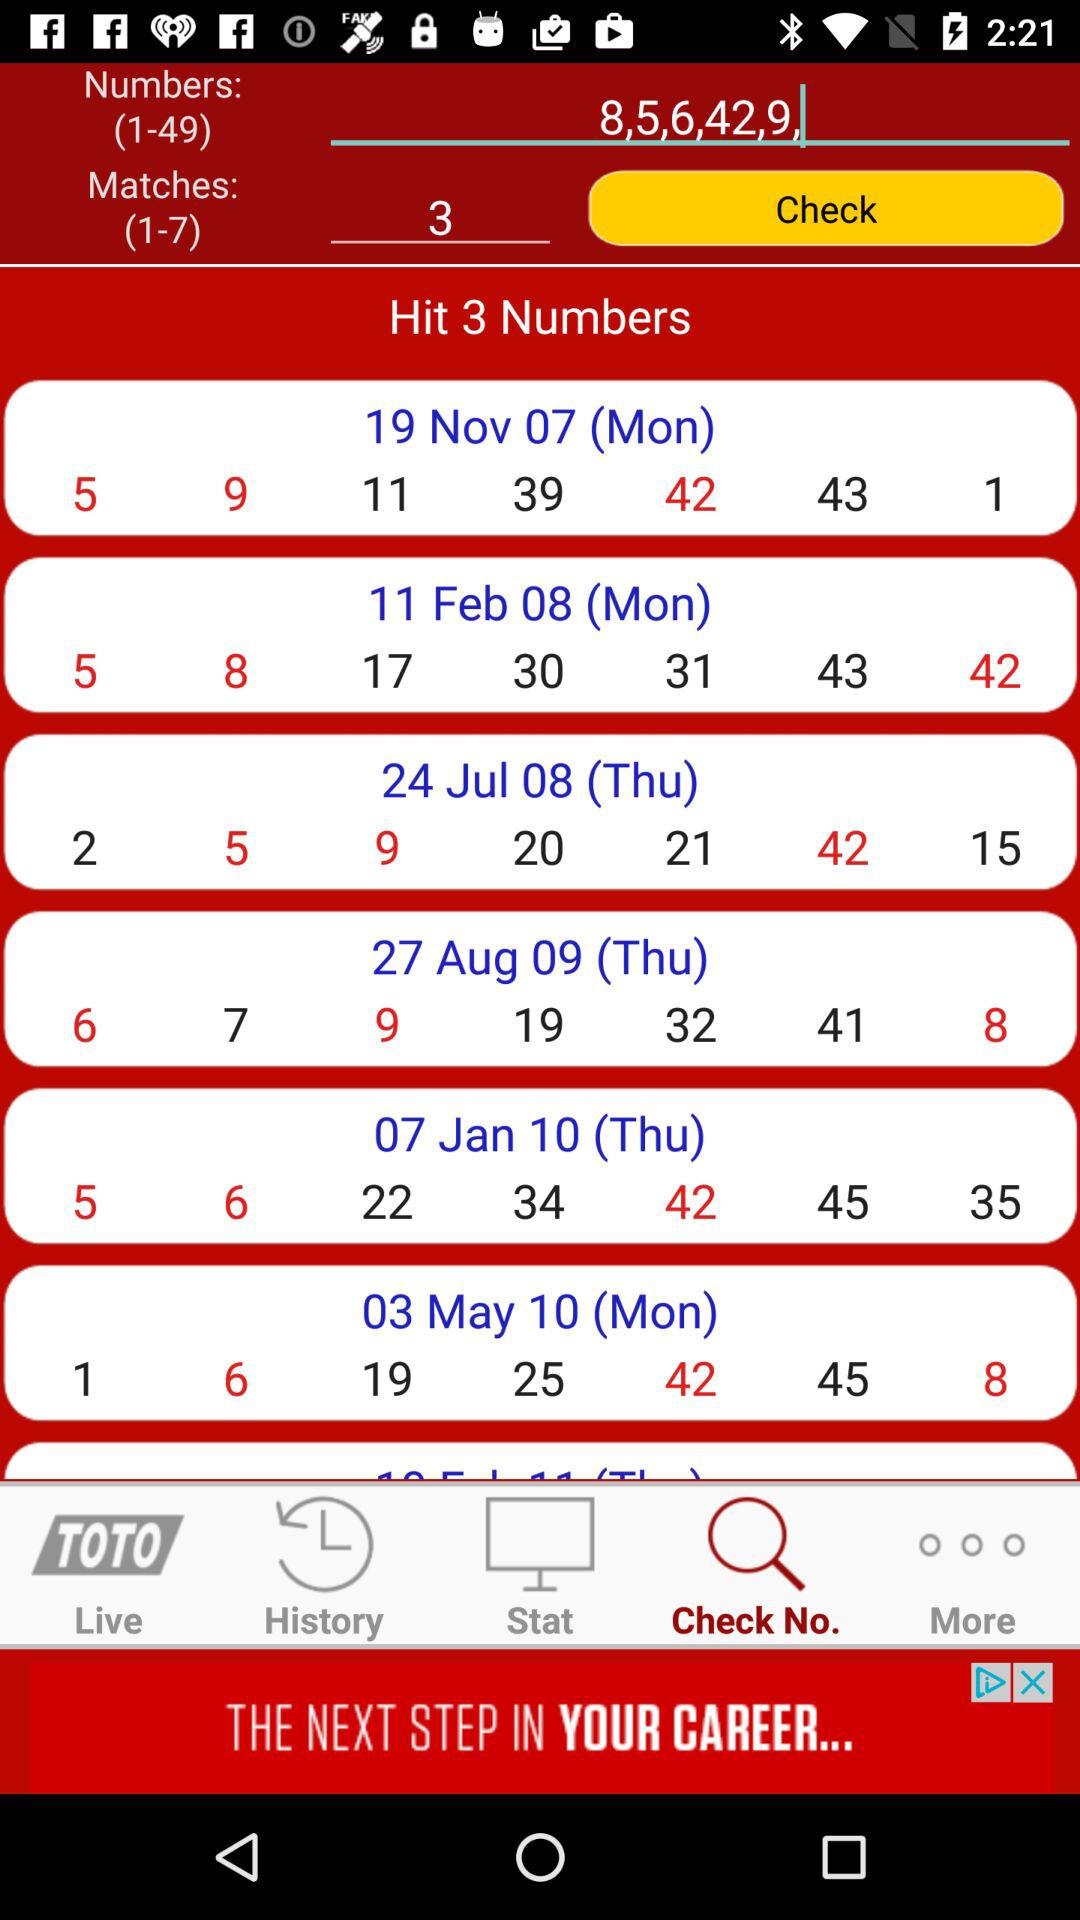What are the different dates available? The different dates are November 19, 07 (Monday), February 11, 08 (Monday), July 24, 08 (Thursday), August 27, 09 (Thursday), January 7, 10 (Thursday), and May 3, 10 (Monday). 